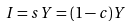<formula> <loc_0><loc_0><loc_500><loc_500>I = s Y = ( 1 - c ) Y</formula> 